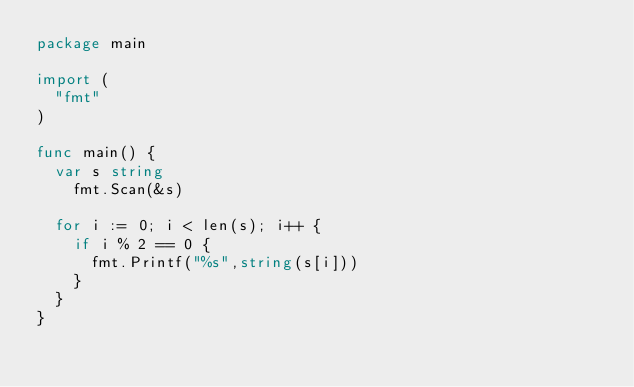Convert code to text. <code><loc_0><loc_0><loc_500><loc_500><_Go_>package main

import (
	"fmt"
)

func main() {
	var s string
  	fmt.Scan(&s)
  	
  for i := 0; i < len(s); i++ {
    if i % 2 == 0 {
      fmt.Printf("%s",string(s[i]))
    }
  }
}</code> 